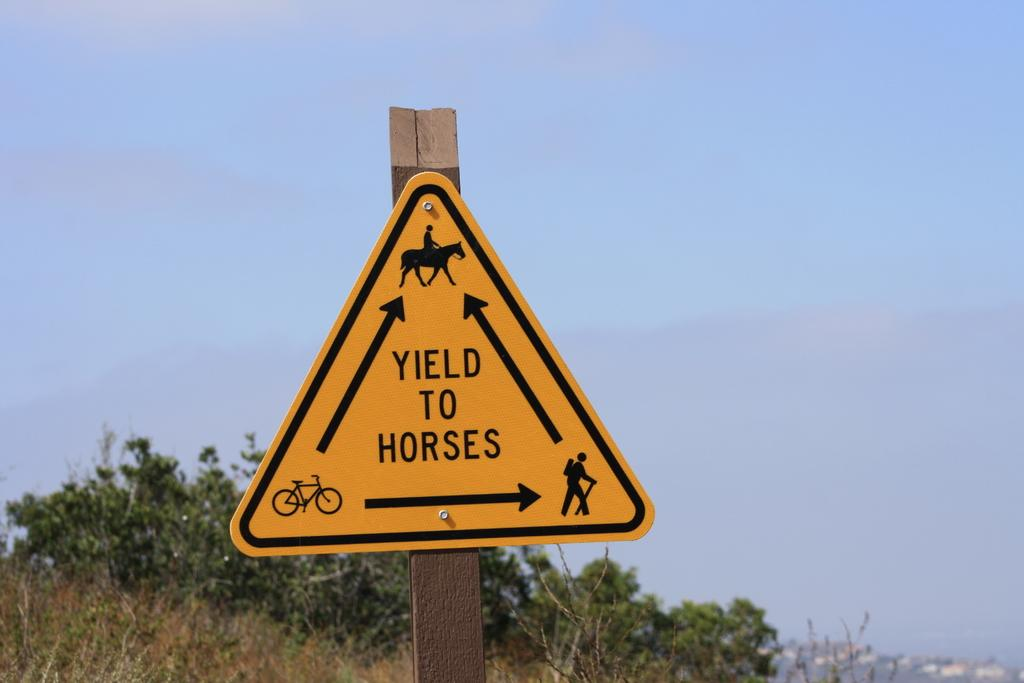<image>
Share a concise interpretation of the image provided. A yellow street sign warns people to Yield To Horses. 